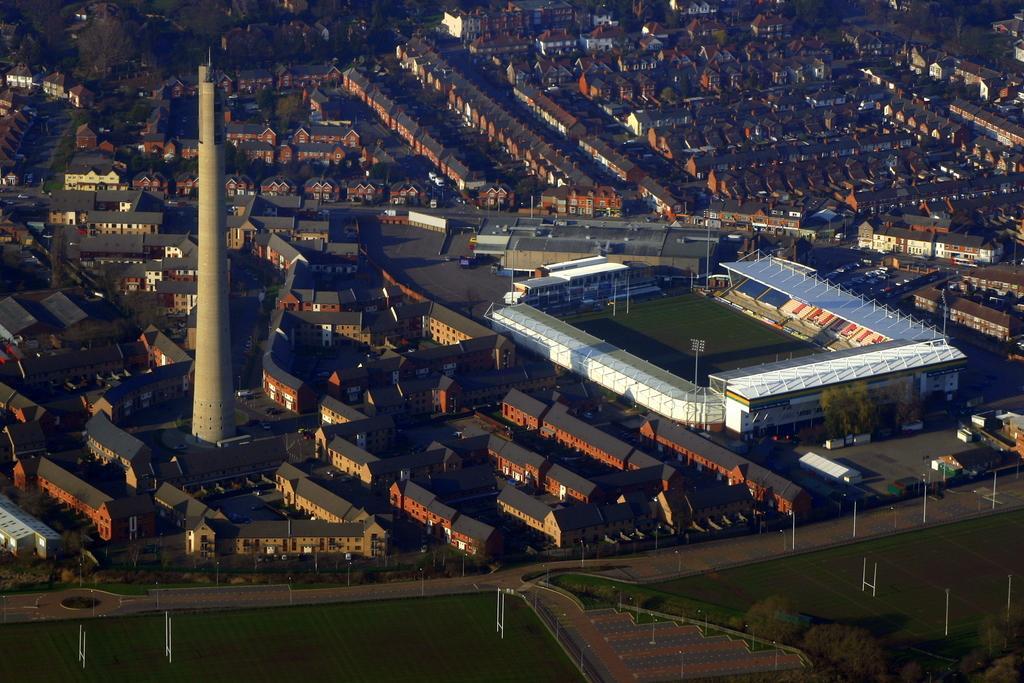In one or two sentences, can you explain what this image depicts? This is a top view image of a city, in this image we can see buildings, a tower and a rugby stadium. 